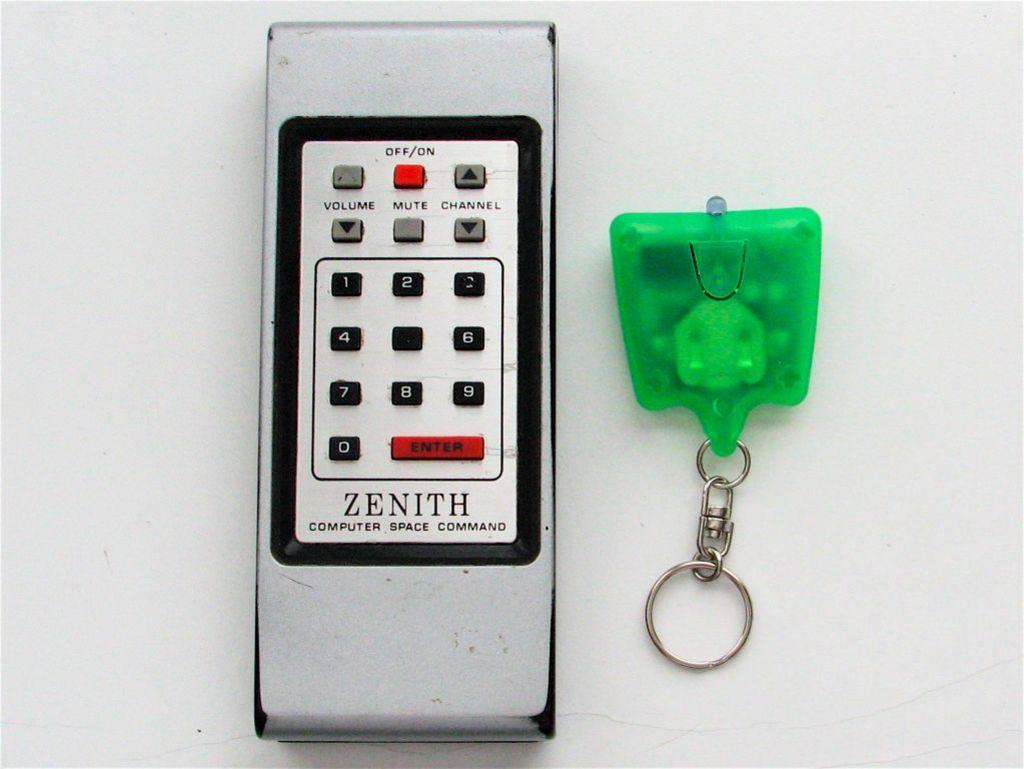<image>
Create a compact narrative representing the image presented. An old Zenith remote control sits next to a green keychain. 